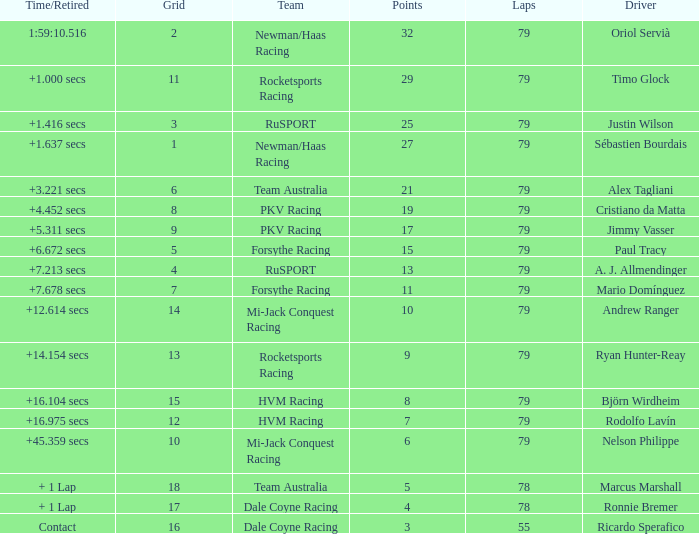What grid has 78 laps, and Ronnie Bremer as driver? 17.0. 